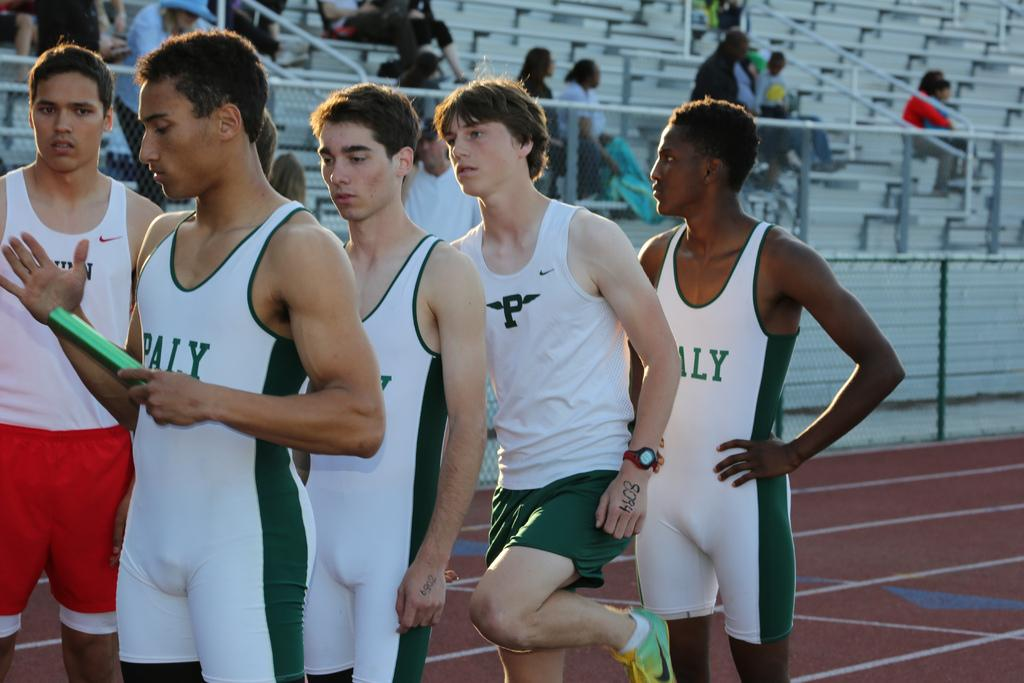<image>
Describe the image concisely. Four members of the PALY relay track team line up. 